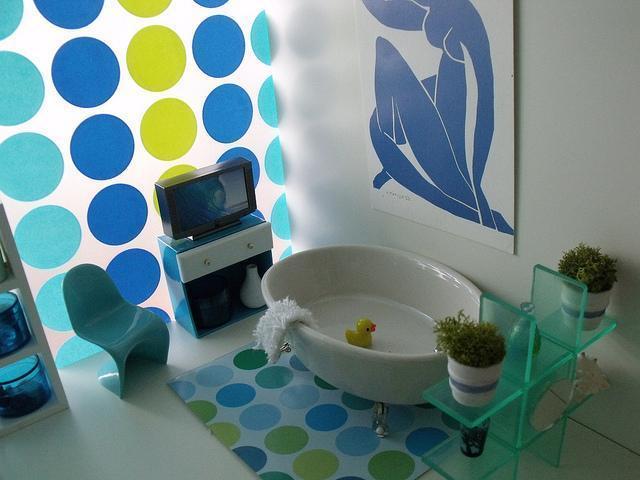How many potted plants can be seen?
Give a very brief answer. 2. How many tvs are there?
Give a very brief answer. 1. 